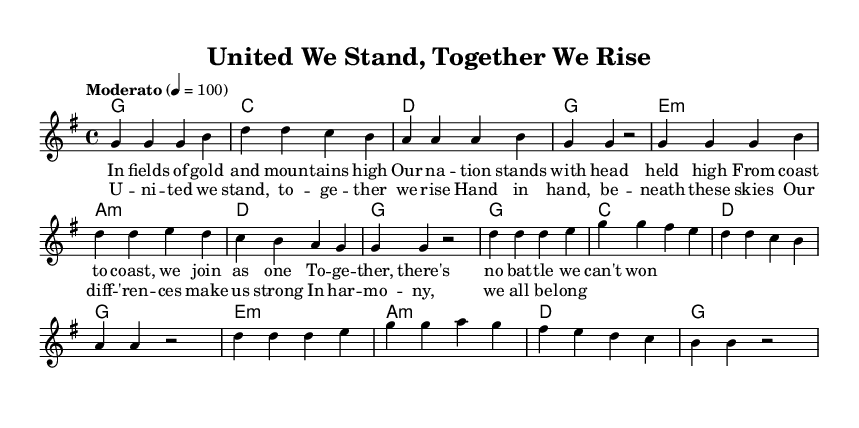What is the key signature of this music? The key signature indicated at the beginning of the sheet music is G major, which has one sharp (F#).
Answer: G major What is the time signature of this music? The time signature located at the start of the music is 4/4, meaning there are four beats in each measure.
Answer: 4/4 What is the tempo of the piece? The tempo marking specifies "Moderato," with a metronome indication of 100 beats per minute, suggesting a moderate pace.
Answer: Moderato, 100 How many measures are in the verse? By counting the individual groups of notes separated by vertical lines, the verse section has 8 measures.
Answer: 8 What is the first note of the chorus? The first note of the chorus, as indicated by the melody written in the staff, is D.
Answer: D How many chords are used in the chorus section? By analyzing the chord symbols written above the staff, the chorus section contains 7 chords indicated in the harmonic progression.
Answer: 7 What is the theme of the anthem? The lyrics convey a theme of unity and working together for a common goal, as seen in phrases discussing standing together and belonging in harmony.
Answer: Unity 